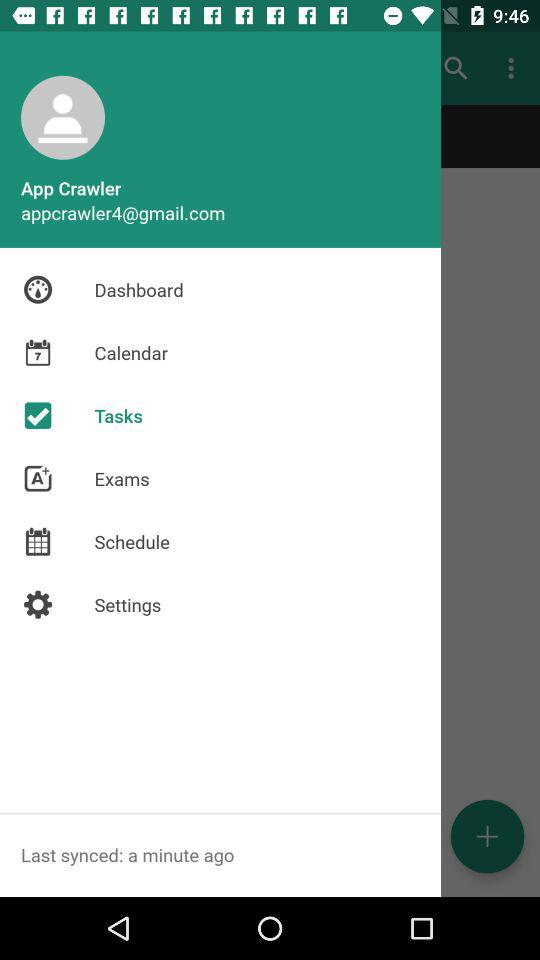What is the user name? The user name is App Crawler. 